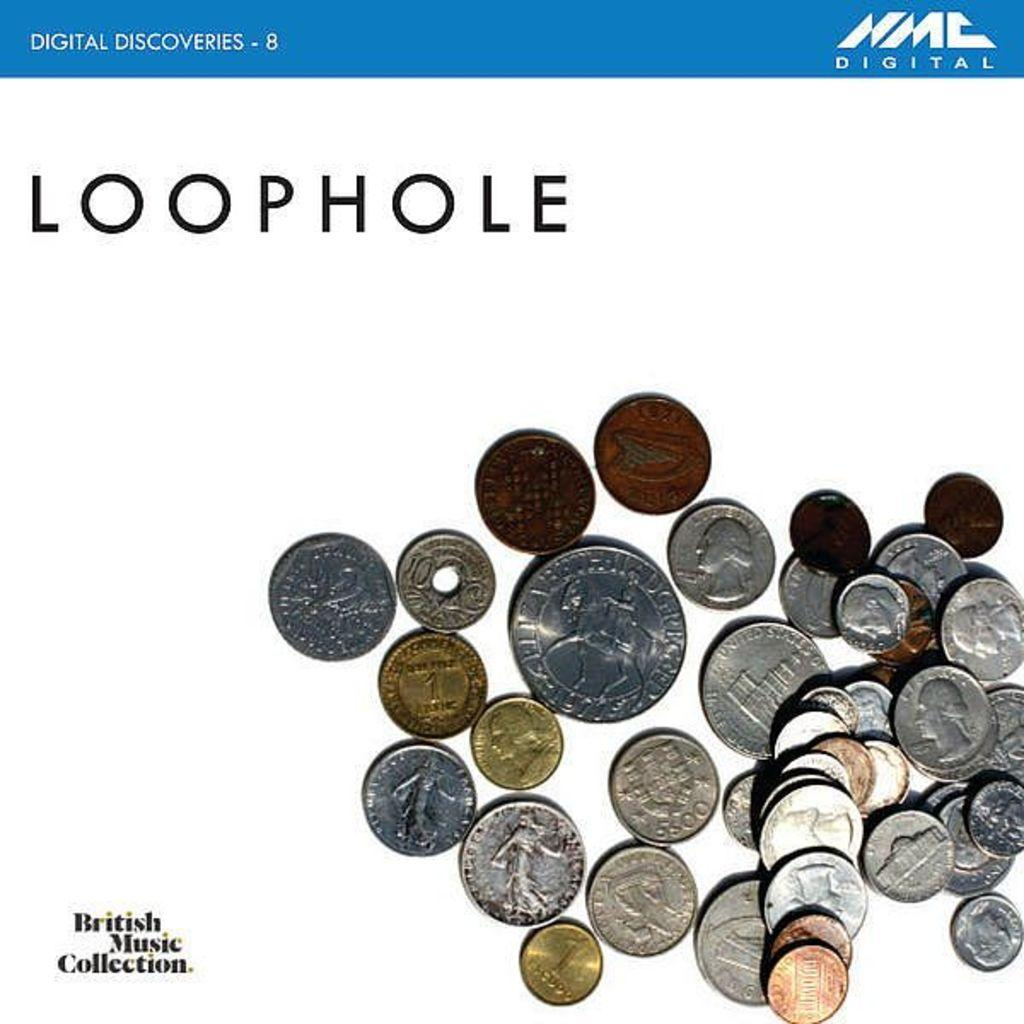<image>
Provide a brief description of the given image. LOOPHOLE in capital letters is above a pile of coins from assorted countries. 